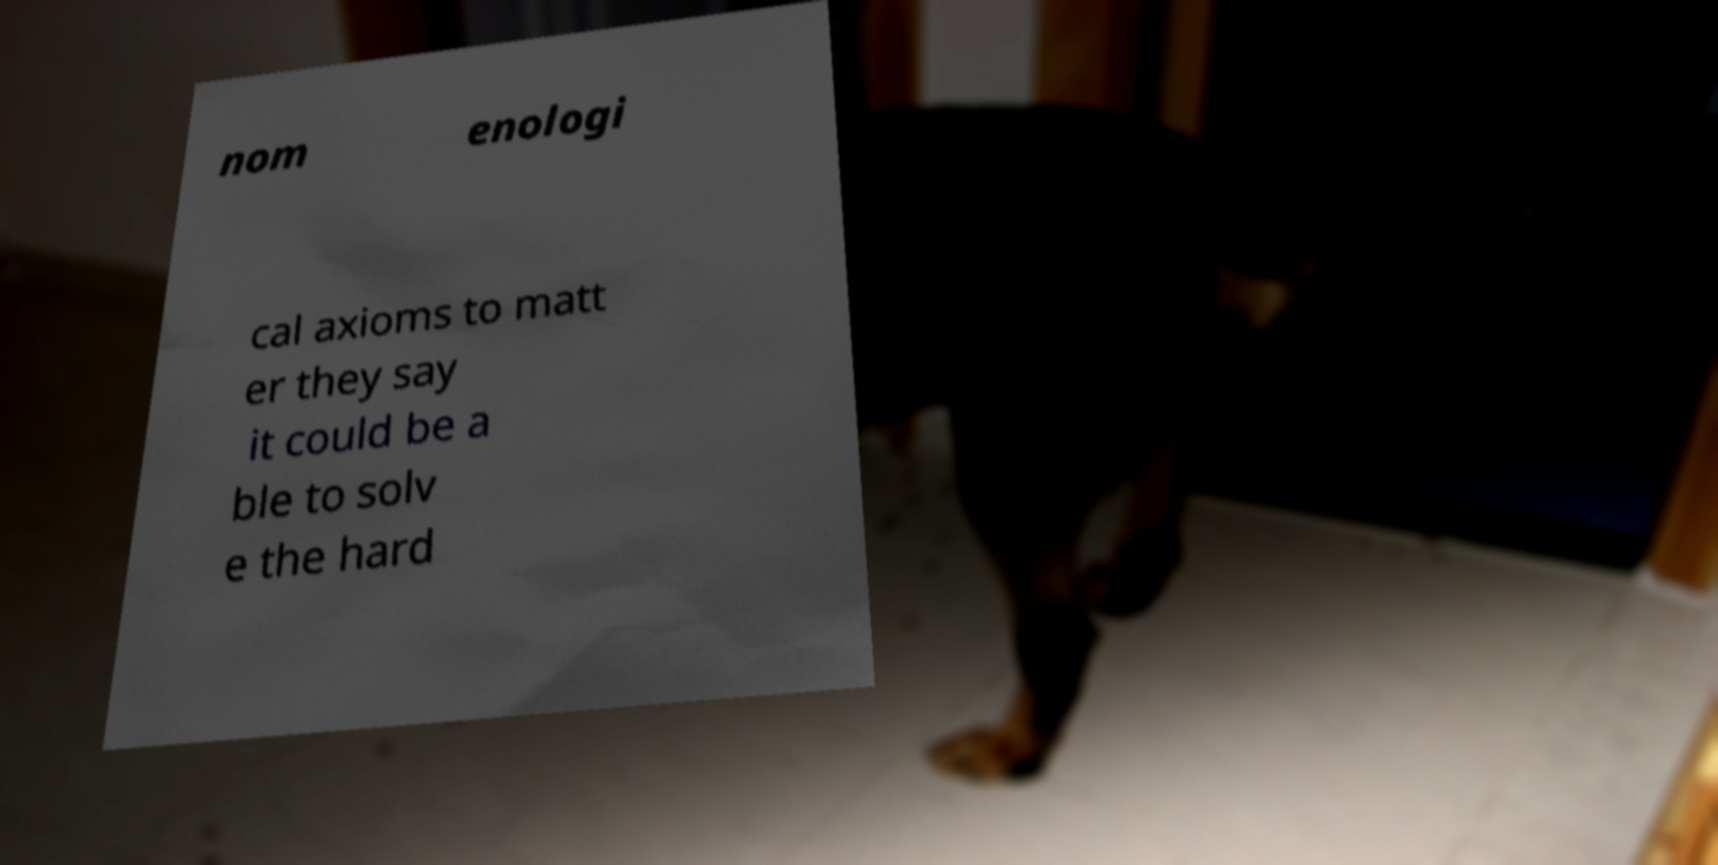Please identify and transcribe the text found in this image. nom enologi cal axioms to matt er they say it could be a ble to solv e the hard 